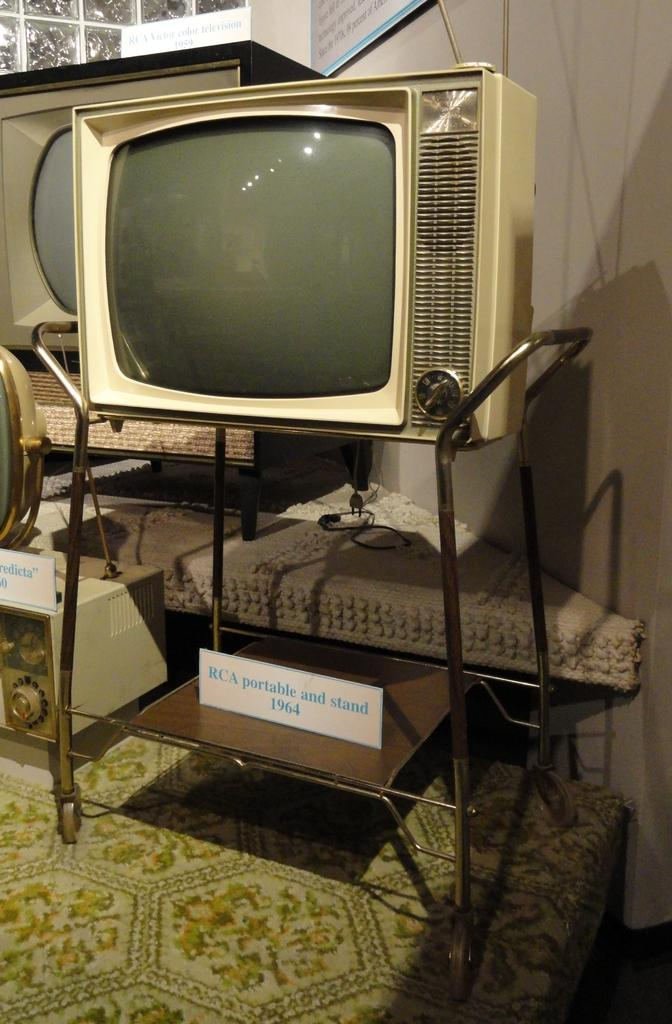<image>
Write a terse but informative summary of the picture. A vintage TV and stand is from all the way back in the year 1964. 